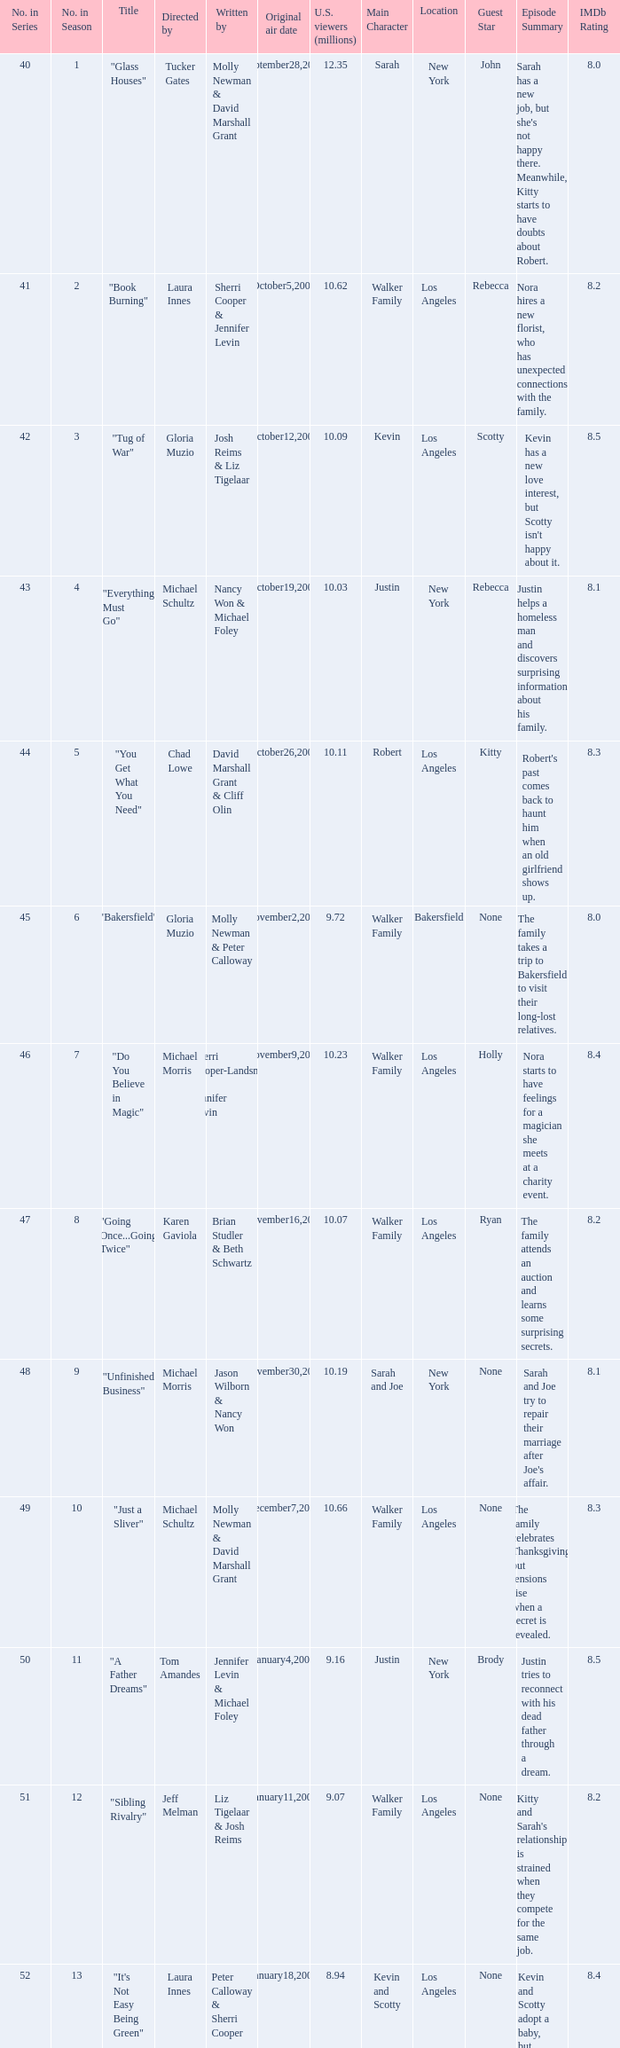What's the name of the episode seen by 9.63 millions of people in the US, whose director is Laura Innes? "S3X". 